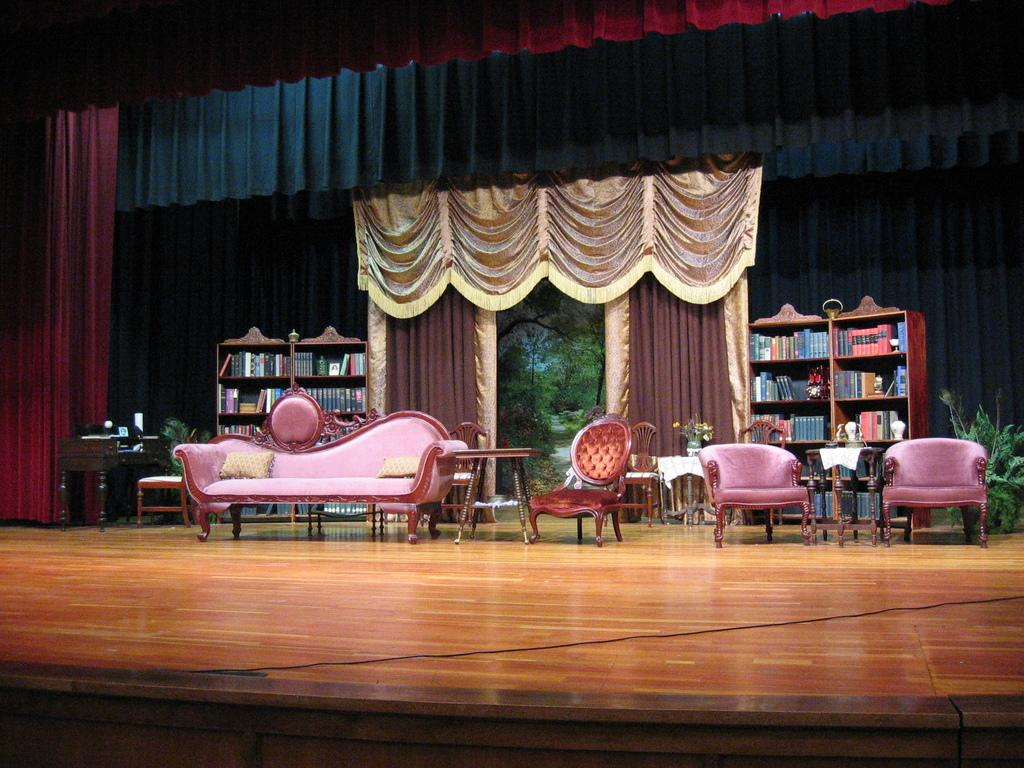What type of furniture is on the stage in the image? There is a sofa, chairs, and a table on the stage in the image. What can be seen in the background of the image? There is a curtain, books, and a plant in the background. How many pieces of furniture are on the stage? There are three pieces of furniture on the stage: a sofa, chairs, and a table. Can you see a bat flying around in the image? No, there is no bat visible in the image. What color is the curtain in the image? The provided facts do not mention the color of the curtain, so we cannot determine its color from the image. 